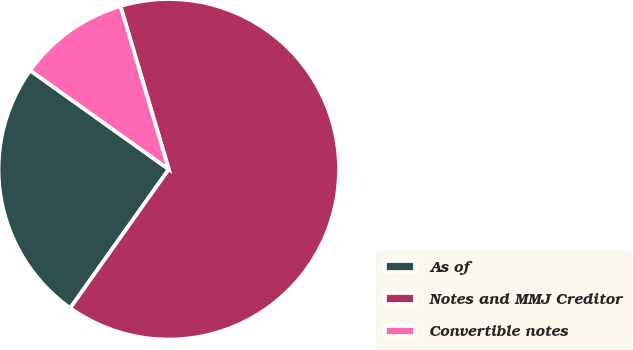<chart> <loc_0><loc_0><loc_500><loc_500><pie_chart><fcel>As of<fcel>Notes and MMJ Creditor<fcel>Convertible notes<nl><fcel>25.03%<fcel>64.4%<fcel>10.56%<nl></chart> 